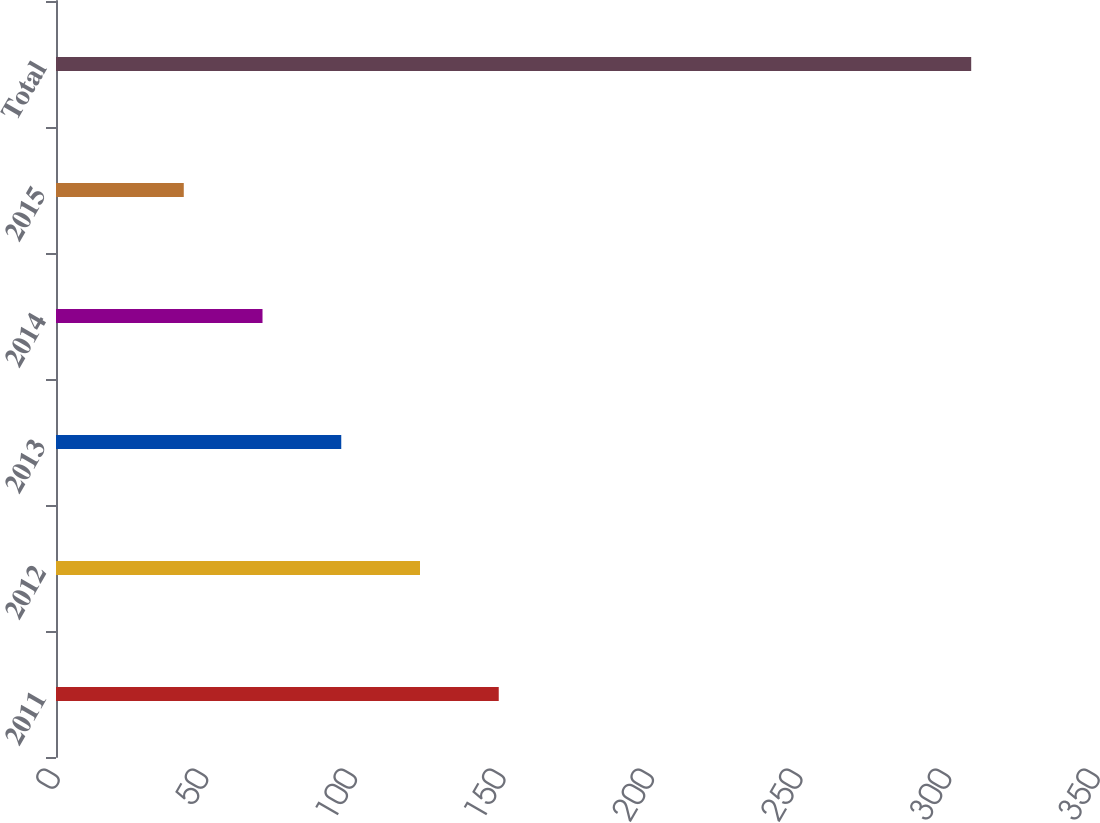Convert chart to OTSL. <chart><loc_0><loc_0><loc_500><loc_500><bar_chart><fcel>2011<fcel>2012<fcel>2013<fcel>2014<fcel>2015<fcel>Total<nl><fcel>149<fcel>122.5<fcel>96<fcel>69.5<fcel>43<fcel>308<nl></chart> 